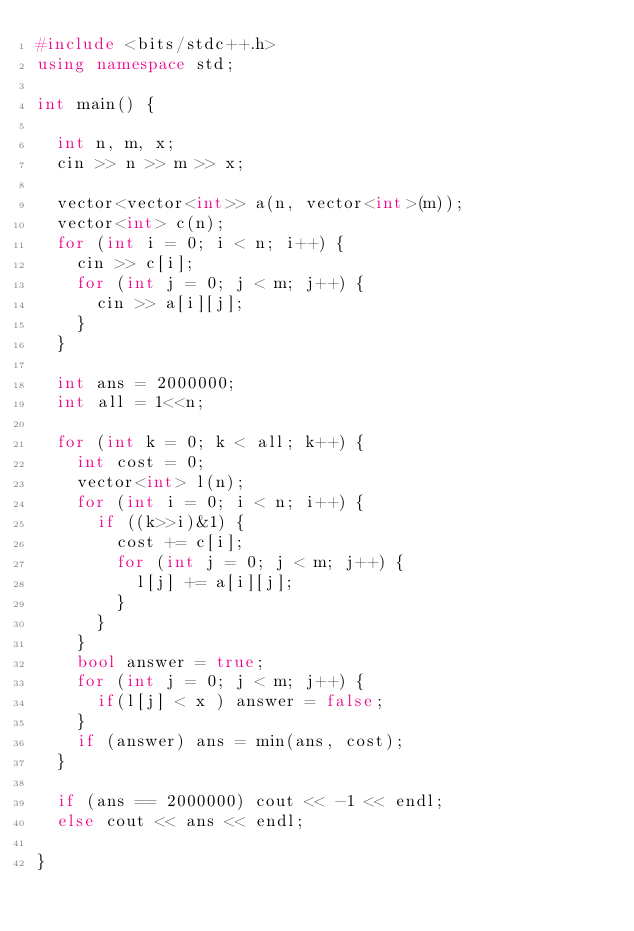<code> <loc_0><loc_0><loc_500><loc_500><_C++_>#include <bits/stdc++.h>
using namespace std;

int main() {
  
  int n, m, x;
  cin >> n >> m >> x;
  
  vector<vector<int>> a(n, vector<int>(m));
  vector<int> c(n);
  for (int i = 0; i < n; i++) {
    cin >> c[i];
    for (int j = 0; j < m; j++) {
      cin >> a[i][j];
    }
  }
  
  int ans = 2000000;
  int all = 1<<n;
  
  for (int k = 0; k < all; k++) {
    int cost = 0;
    vector<int> l(n);
    for (int i = 0; i < n; i++) {
      if ((k>>i)&1) {
        cost += c[i];
        for (int j = 0; j < m; j++) {
          l[j] += a[i][j];
        }
      }
    }
    bool answer = true;
    for (int j = 0; j < m; j++) {
      if(l[j] < x ) answer = false;
    }
    if (answer) ans = min(ans, cost);
  }
  
  if (ans == 2000000) cout << -1 << endl;
  else cout << ans << endl;
  
}</code> 